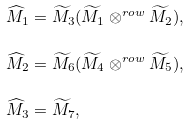Convert formula to latex. <formula><loc_0><loc_0><loc_500><loc_500>\widehat { M } _ { 1 } & = \widetilde { M } _ { 3 } ( \widetilde { M } _ { 1 } \otimes ^ { r o w } \widetilde { M } _ { 2 } ) , \\ \widehat { M } _ { 2 } & = \widetilde { M } _ { 6 } ( \widetilde { M } _ { 4 } \otimes ^ { r o w } \widetilde { M } _ { 5 } ) , \\ \widehat { M } _ { 3 } & = \widetilde { M } _ { 7 } ,</formula> 